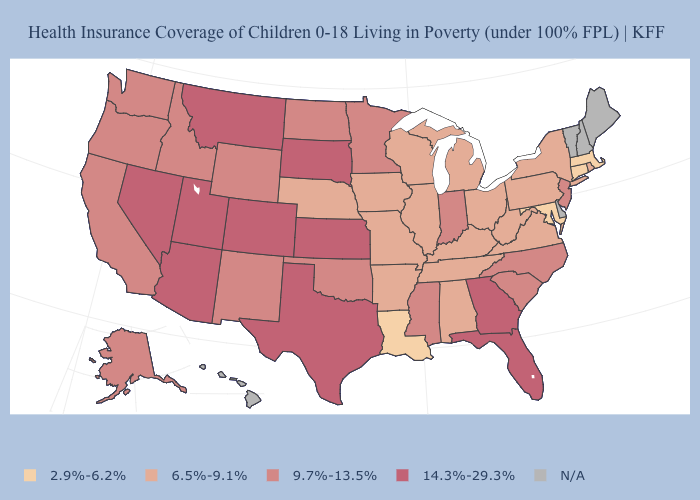Is the legend a continuous bar?
Quick response, please. No. What is the value of Connecticut?
Keep it brief. 2.9%-6.2%. Which states have the highest value in the USA?
Short answer required. Arizona, Colorado, Florida, Georgia, Kansas, Montana, Nevada, South Dakota, Texas, Utah. How many symbols are there in the legend?
Short answer required. 5. What is the value of Wyoming?
Short answer required. 9.7%-13.5%. What is the value of Pennsylvania?
Quick response, please. 6.5%-9.1%. Does the map have missing data?
Short answer required. Yes. Is the legend a continuous bar?
Write a very short answer. No. Name the states that have a value in the range 9.7%-13.5%?
Keep it brief. Alaska, California, Idaho, Indiana, Minnesota, Mississippi, New Jersey, New Mexico, North Carolina, North Dakota, Oklahoma, Oregon, South Carolina, Washington, Wyoming. Name the states that have a value in the range N/A?
Give a very brief answer. Delaware, Hawaii, Maine, New Hampshire, Vermont. What is the value of Mississippi?
Answer briefly. 9.7%-13.5%. Which states have the highest value in the USA?
Concise answer only. Arizona, Colorado, Florida, Georgia, Kansas, Montana, Nevada, South Dakota, Texas, Utah. Among the states that border Wisconsin , which have the lowest value?
Keep it brief. Illinois, Iowa, Michigan. Is the legend a continuous bar?
Answer briefly. No. Which states have the lowest value in the South?
Give a very brief answer. Louisiana, Maryland. 